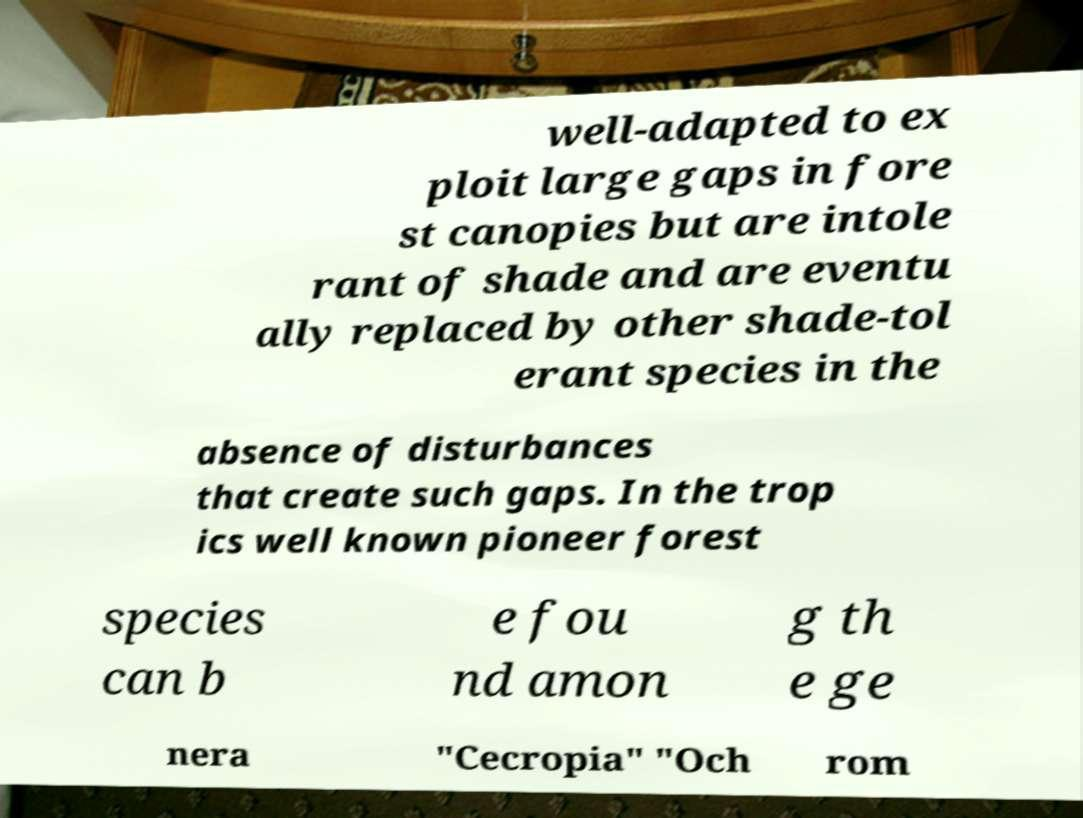What messages or text are displayed in this image? I need them in a readable, typed format. well-adapted to ex ploit large gaps in fore st canopies but are intole rant of shade and are eventu ally replaced by other shade-tol erant species in the absence of disturbances that create such gaps. In the trop ics well known pioneer forest species can b e fou nd amon g th e ge nera "Cecropia" "Och rom 